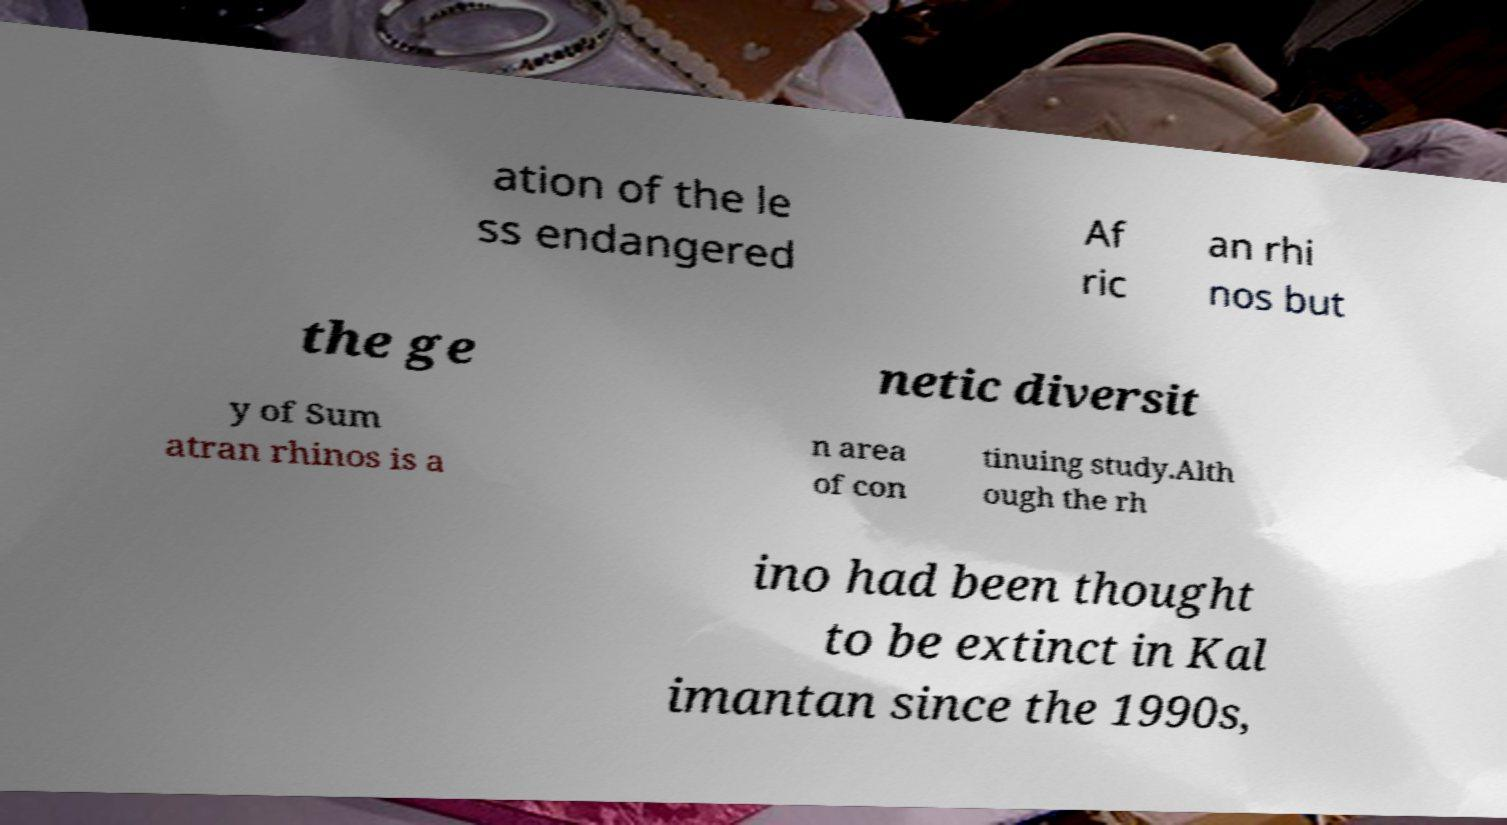Please identify and transcribe the text found in this image. ation of the le ss endangered Af ric an rhi nos but the ge netic diversit y of Sum atran rhinos is a n area of con tinuing study.Alth ough the rh ino had been thought to be extinct in Kal imantan since the 1990s, 